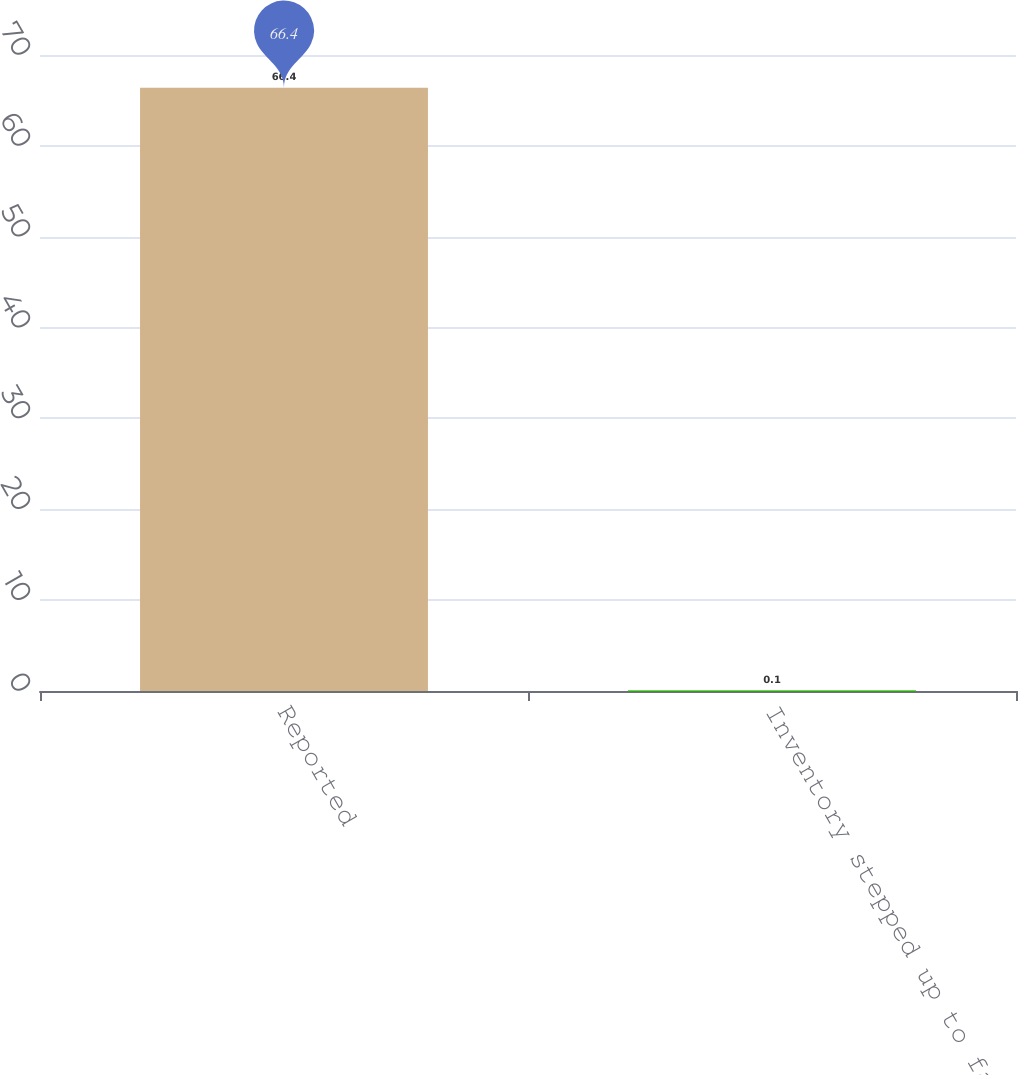<chart> <loc_0><loc_0><loc_500><loc_500><bar_chart><fcel>Reported<fcel>Inventory stepped up to fair<nl><fcel>66.4<fcel>0.1<nl></chart> 